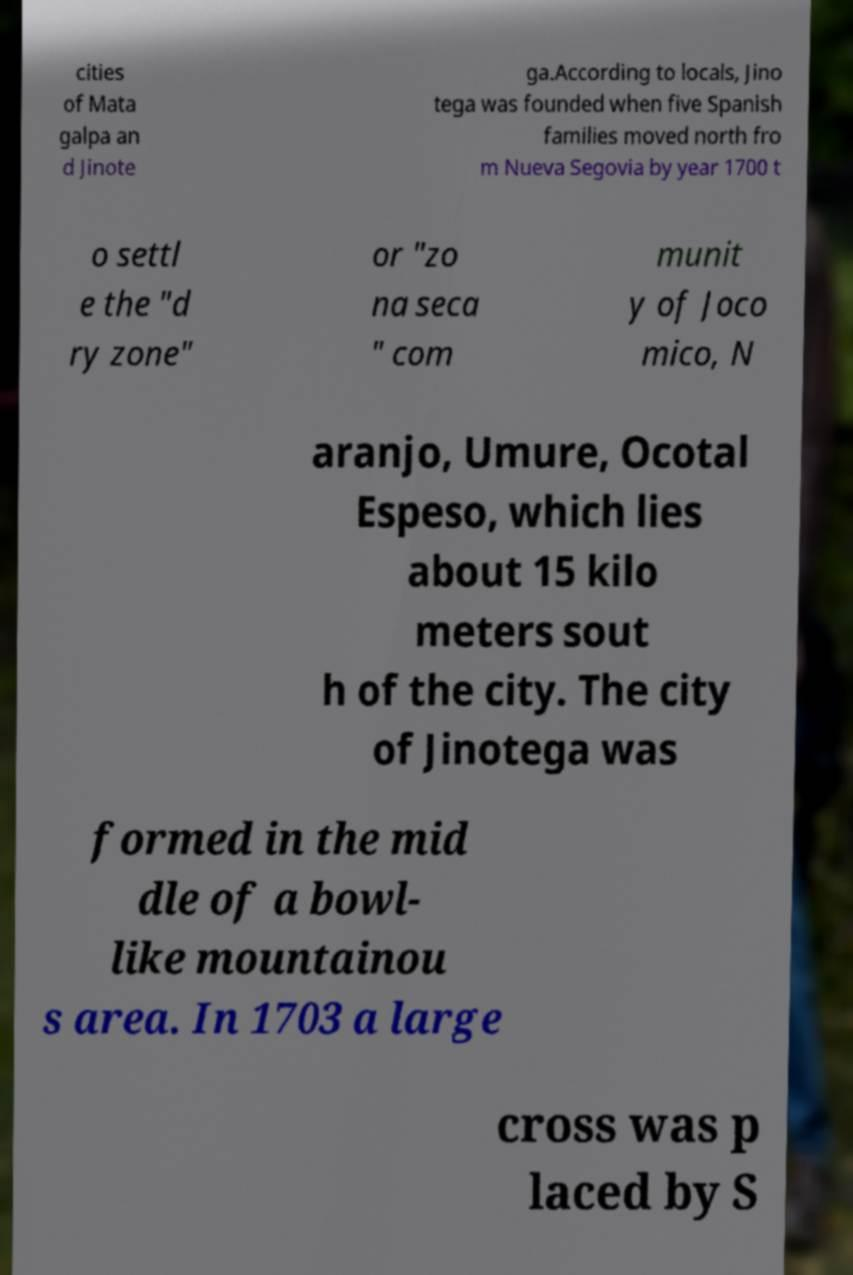I need the written content from this picture converted into text. Can you do that? cities of Mata galpa an d Jinote ga.According to locals, Jino tega was founded when five Spanish families moved north fro m Nueva Segovia by year 1700 t o settl e the "d ry zone" or "zo na seca " com munit y of Joco mico, N aranjo, Umure, Ocotal Espeso, which lies about 15 kilo meters sout h of the city. The city of Jinotega was formed in the mid dle of a bowl- like mountainou s area. In 1703 a large cross was p laced by S 